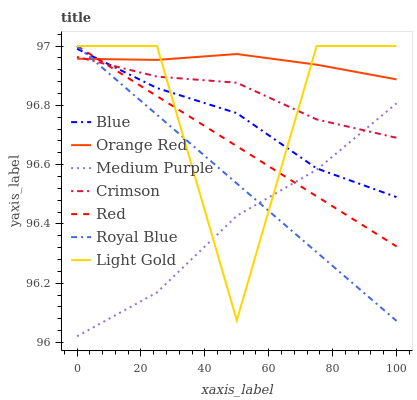Does Medium Purple have the minimum area under the curve?
Answer yes or no. Yes. Does Orange Red have the maximum area under the curve?
Answer yes or no. Yes. Does Royal Blue have the minimum area under the curve?
Answer yes or no. No. Does Royal Blue have the maximum area under the curve?
Answer yes or no. No. Is Red the smoothest?
Answer yes or no. Yes. Is Light Gold the roughest?
Answer yes or no. Yes. Is Medium Purple the smoothest?
Answer yes or no. No. Is Medium Purple the roughest?
Answer yes or no. No. Does Medium Purple have the lowest value?
Answer yes or no. Yes. Does Royal Blue have the lowest value?
Answer yes or no. No. Does Red have the highest value?
Answer yes or no. Yes. Does Medium Purple have the highest value?
Answer yes or no. No. Is Medium Purple less than Orange Red?
Answer yes or no. Yes. Is Orange Red greater than Medium Purple?
Answer yes or no. Yes. Does Crimson intersect Red?
Answer yes or no. Yes. Is Crimson less than Red?
Answer yes or no. No. Is Crimson greater than Red?
Answer yes or no. No. Does Medium Purple intersect Orange Red?
Answer yes or no. No. 